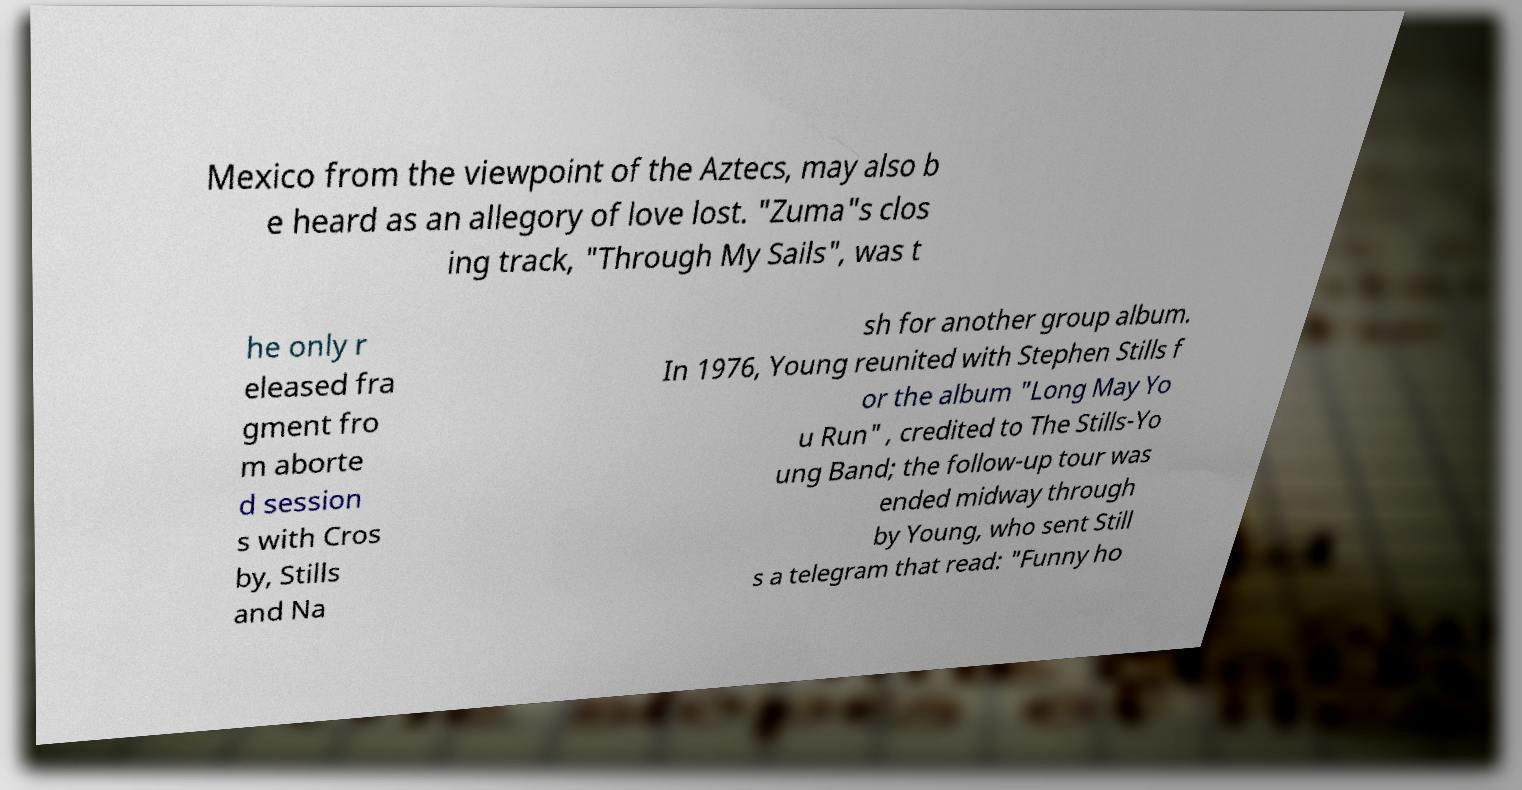There's text embedded in this image that I need extracted. Can you transcribe it verbatim? Mexico from the viewpoint of the Aztecs, may also b e heard as an allegory of love lost. "Zuma"s clos ing track, "Through My Sails", was t he only r eleased fra gment fro m aborte d session s with Cros by, Stills and Na sh for another group album. In 1976, Young reunited with Stephen Stills f or the album "Long May Yo u Run" , credited to The Stills-Yo ung Band; the follow-up tour was ended midway through by Young, who sent Still s a telegram that read: "Funny ho 